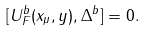<formula> <loc_0><loc_0><loc_500><loc_500>[ U _ { F } ^ { b } ( x _ { \mu } , y ) , \Delta ^ { b } ] = 0 .</formula> 